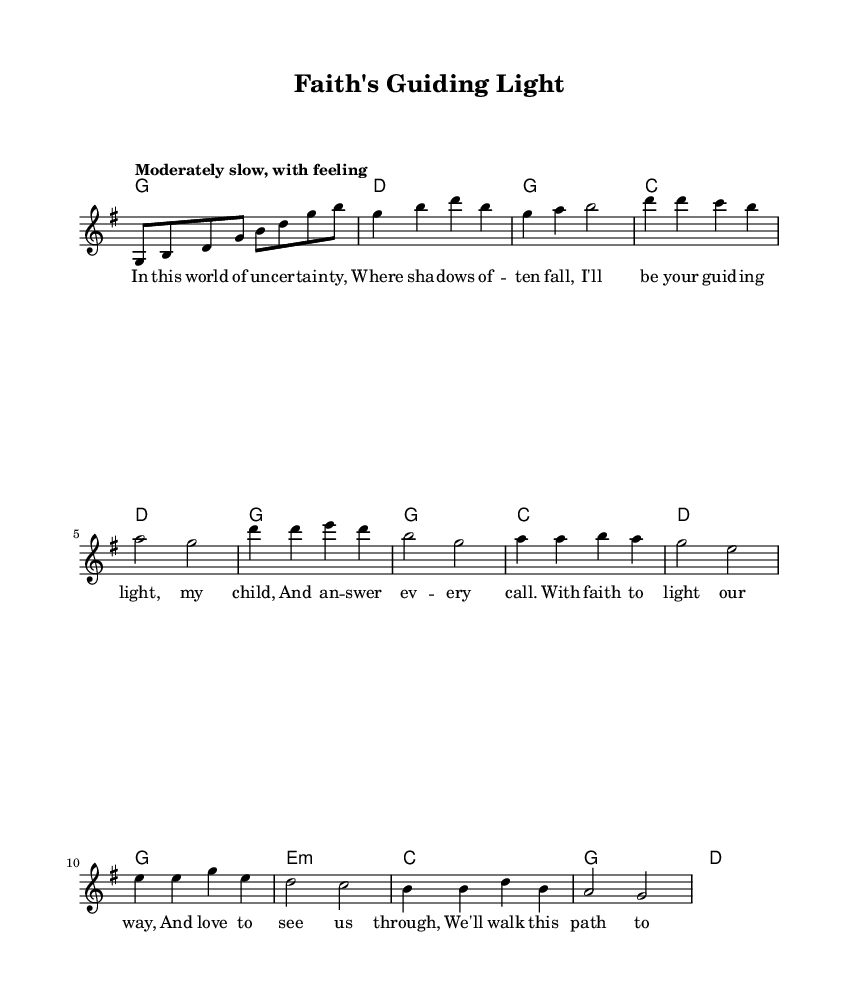What is the key signature of this music? The key signature shown at the beginning of the score indicates G major, which has one sharp (F#).
Answer: G major What is the time signature of the piece? The time signature in the music is 4/4, which means there are four beats per measure.
Answer: 4/4 What is the tempo marking for this piece? The tempo marking specifies "Moderately slow, with feeling," indicating the intended expression and pace of the music.
Answer: Moderately slow, with feeling How many measures are there in the verse? By counting the measures listed under the verse section, we find there are four measures total.
Answer: Four measures What are the first two words of the chorus? The chorus begins with the words "With faith," which are the first two words as indicated in the lyrics under that section.
Answer: With faith What is the primary theme of the lyrics expressed in this song? The primary theme centers on faith and the bond between parent and child, emphasizing guidance and support.
Answer: Faith and guidance What chord is played during the bridge section? The bridge section starts with an E minor chord, as indicated in the harmonies part of the score.
Answer: E minor 